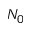<formula> <loc_0><loc_0><loc_500><loc_500>N _ { 0 }</formula> 